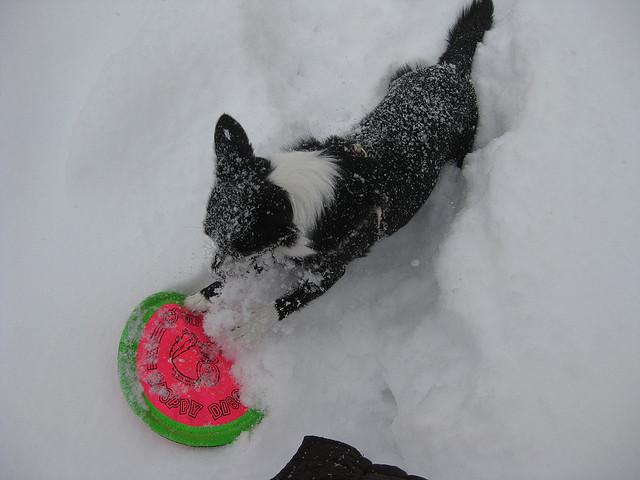What is the dog riding on?
Quick response, please. Frisbee. Is this dog having a fun day at the beach?
Keep it brief. No. What color at the tips of its paws?
Give a very brief answer. White. How deep down in the snow did the dog dig to reach the Frisbee?
Quick response, please. 6 inches. Is the dog playing in the dirt?
Quick response, please. No. What color is the dog's toy?
Concise answer only. Pink and green. What type of weather is the dog playing in?
Write a very short answer. Snow. What color is the frisbee?
Give a very brief answer. Pink and green. 